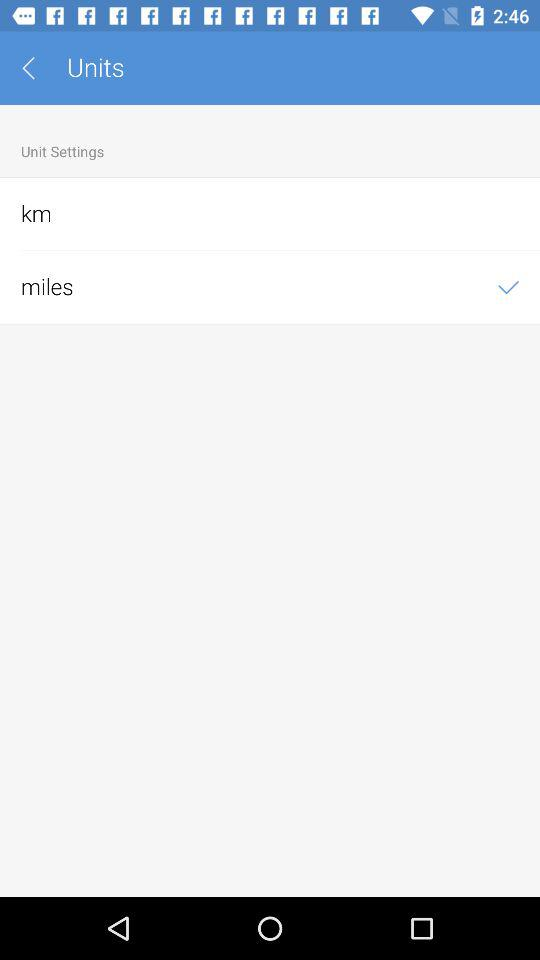Which option is checked? The checked option is "miles". 